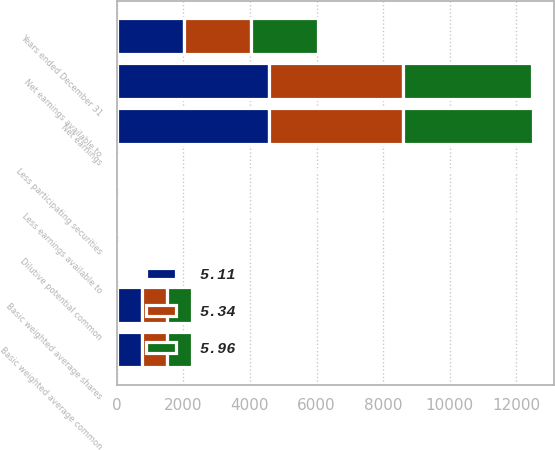Convert chart to OTSL. <chart><loc_0><loc_0><loc_500><loc_500><stacked_bar_chart><ecel><fcel>Years ended December 31<fcel>Net earnings<fcel>Less earnings available to<fcel>Net earnings available to<fcel>Basic weighted average shares<fcel>Less participating securities<fcel>Basic weighted average common<fcel>Dilutive potential common<nl><fcel>5.11<fcel>2013<fcel>4585<fcel>7<fcel>4578<fcel>760.8<fcel>1.9<fcel>758.9<fcel>8.7<nl><fcel>5.96<fcel>2012<fcel>3900<fcel>8<fcel>3892<fcel>758<fcel>2.3<fcel>755.7<fcel>5.8<nl><fcel>5.34<fcel>2011<fcel>4018<fcel>9<fcel>4009<fcel>746.6<fcel>2.5<fcel>744.1<fcel>6.5<nl></chart> 